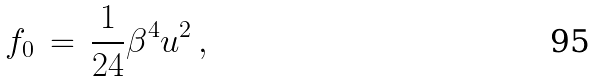<formula> <loc_0><loc_0><loc_500><loc_500>f _ { 0 } \, = \, \frac { 1 } { 2 4 } \beta ^ { 4 } u ^ { 2 } \, ,</formula> 